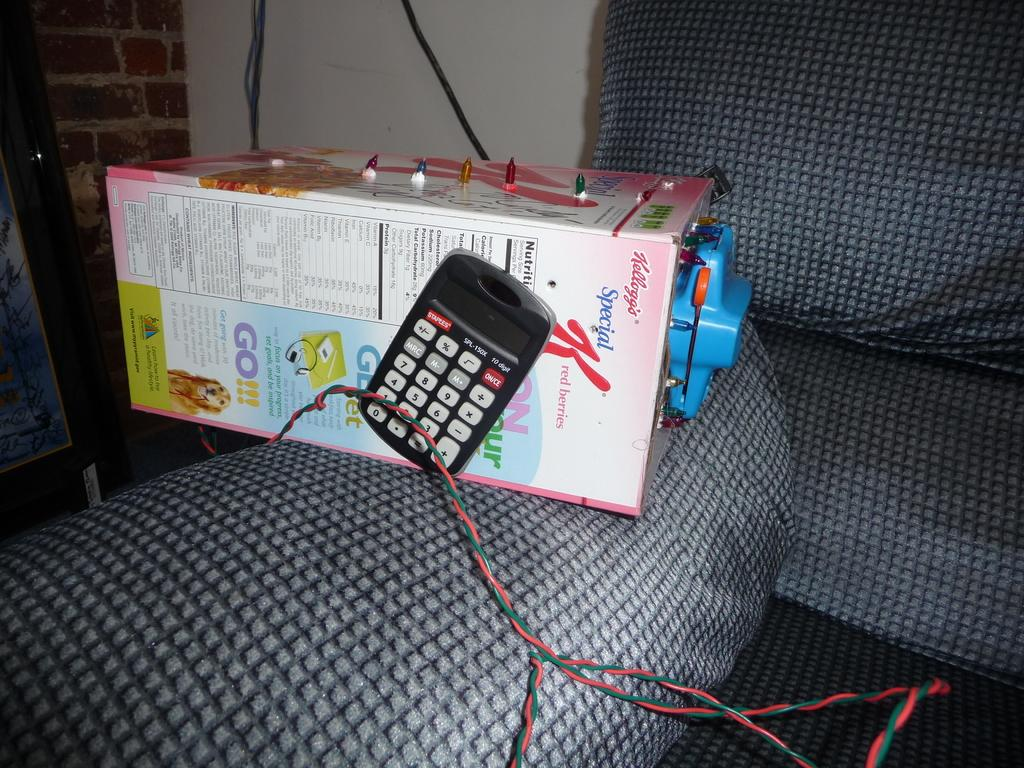Provide a one-sentence caption for the provided image. A calculator is on a box of Special K red berries. 